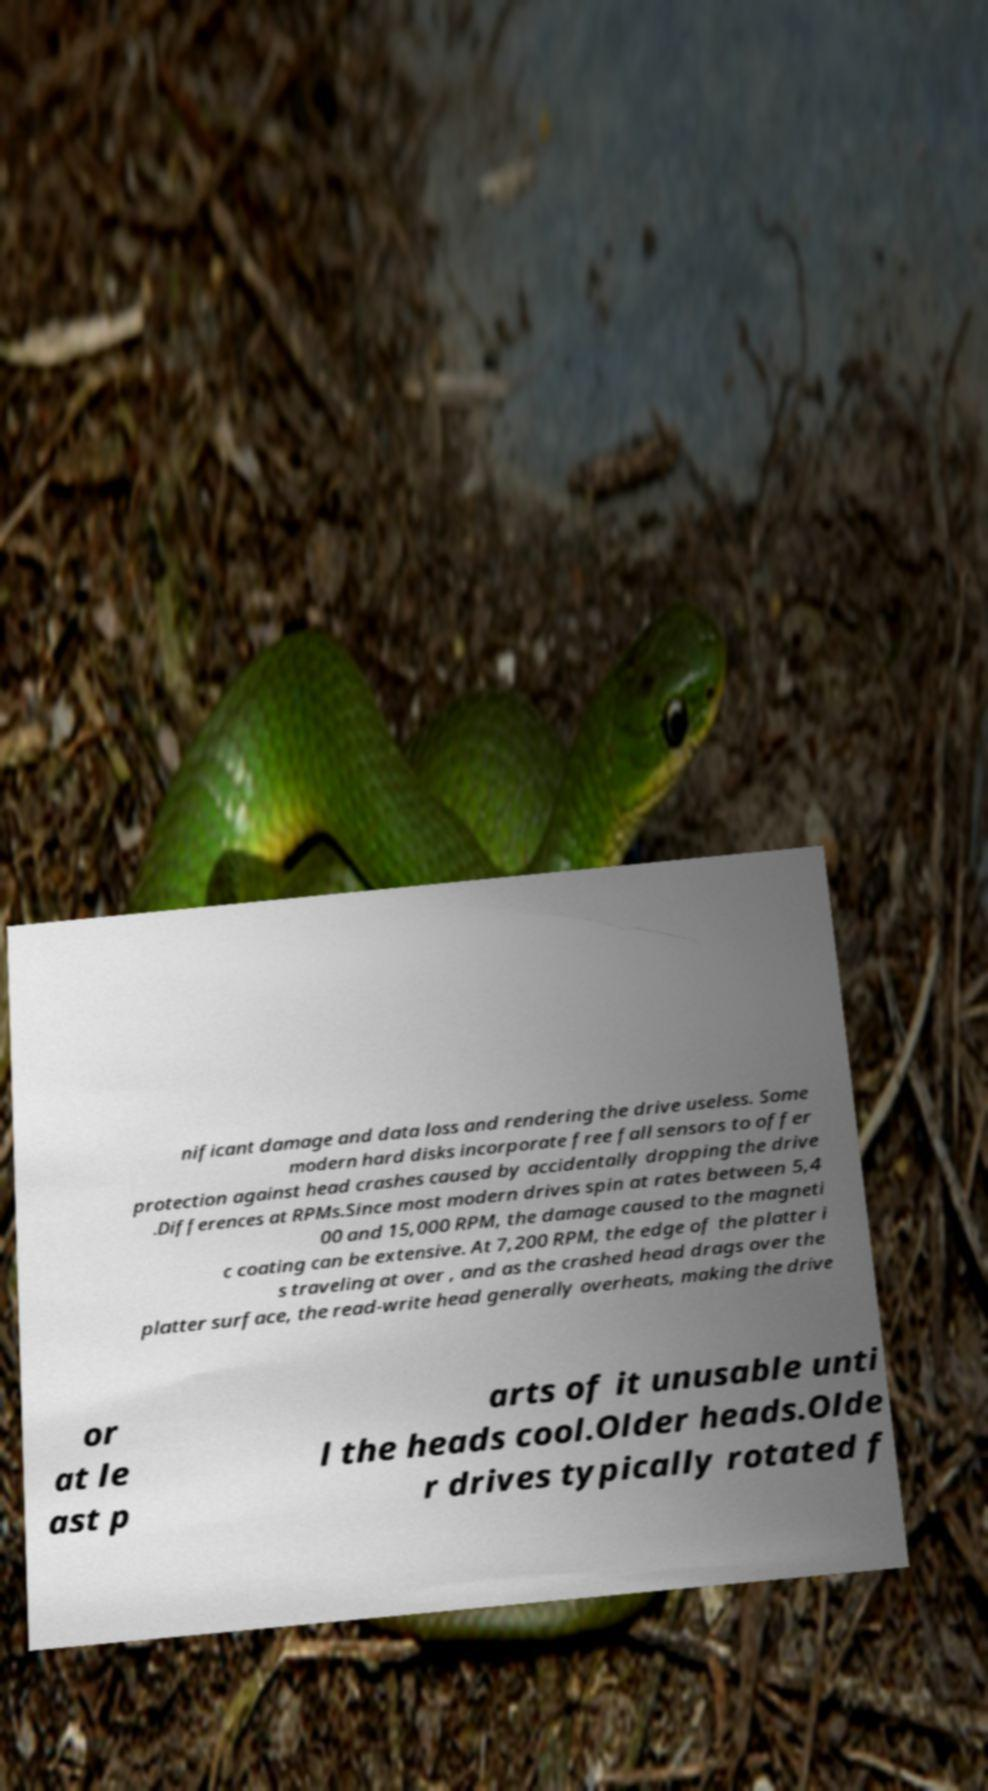For documentation purposes, I need the text within this image transcribed. Could you provide that? nificant damage and data loss and rendering the drive useless. Some modern hard disks incorporate free fall sensors to offer protection against head crashes caused by accidentally dropping the drive .Differences at RPMs.Since most modern drives spin at rates between 5,4 00 and 15,000 RPM, the damage caused to the magneti c coating can be extensive. At 7,200 RPM, the edge of the platter i s traveling at over , and as the crashed head drags over the platter surface, the read-write head generally overheats, making the drive or at le ast p arts of it unusable unti l the heads cool.Older heads.Olde r drives typically rotated f 